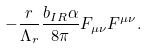Convert formula to latex. <formula><loc_0><loc_0><loc_500><loc_500>- \frac { r } { \Lambda _ { r } } \frac { b _ { I R } \alpha } { 8 \pi } F _ { \mu \nu } F ^ { \mu \nu } .</formula> 